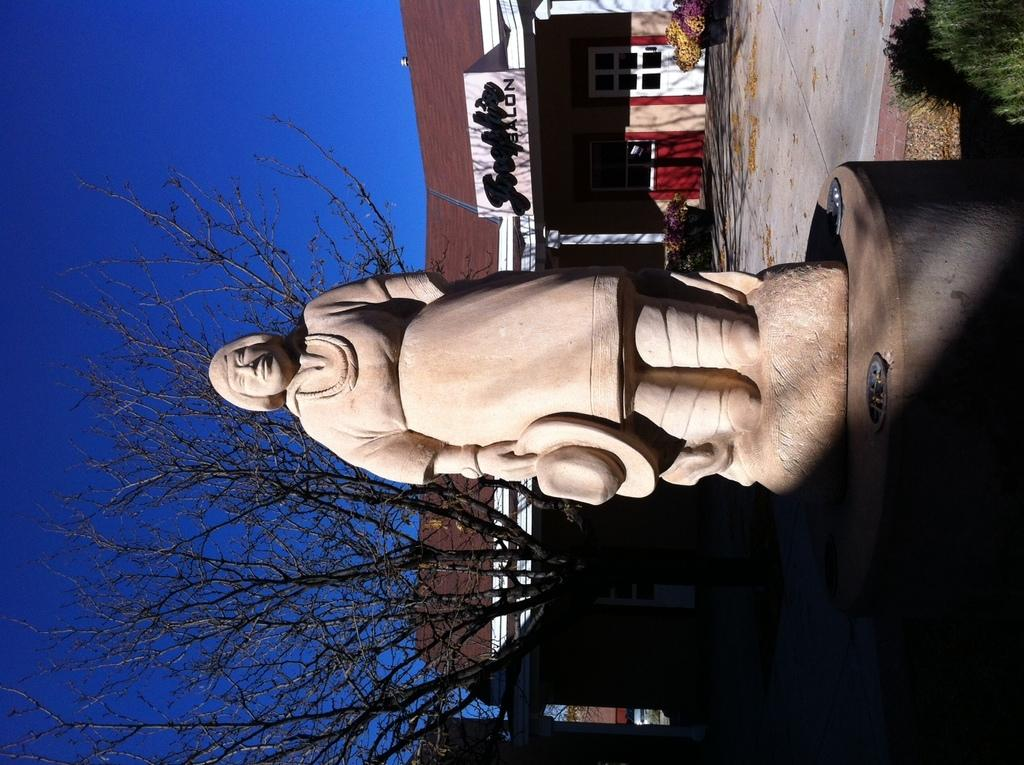What is the main subject in the middle of the picture? There is a statue in the middle of the picture. What is located behind the statue? There is a tree behind the statue. What can be seen in the background of the picture? There is a building visible in the background, and the sky is also visible. What type of committee can be seen meeting near the statue in the image? There is no committee present in the image; it only features a statue, a tree, a building, and the sky. Can you tell me how many bees are buzzing around the statue in the image? There are no bees present in the image; it only features a statue, a tree, a building, and the sky. 